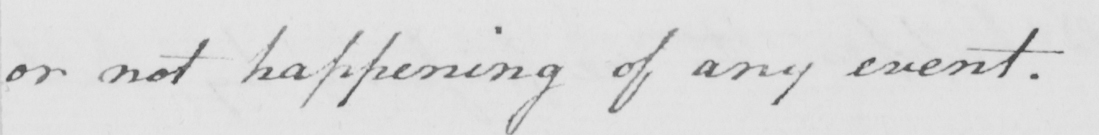Please provide the text content of this handwritten line. or not happening of any event . 